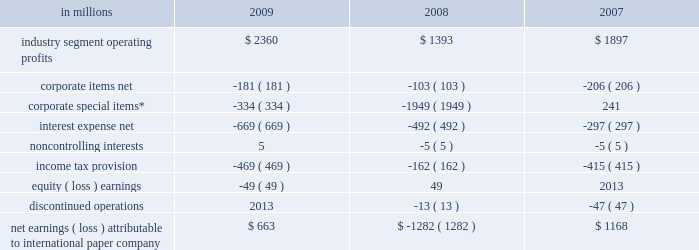Item 7 .
Management 2019s discussion and analysis of financial condition and results of operations executive summary international paper company reported net sales of $ 23.4 billion in 2009 , compared with $ 24.8 billion in 2008 and $ 21.9 billion in 2007 .
Net earnings totaled $ 663 million in 2009 , including $ 1.4 billion of alter- native fuel mixture credits and $ 853 million of charges to restructure ongoing businesses , com- pared with a loss of $ 1.3 billion in 2008 , which included a $ 1.8 billion goodwill impairment charge .
Net earnings in 2007 totaled $ 1.2 billion .
The company performed well in 2009 considering the magnitude of the challenges it faced , both domestically and around the world .
Despite weak global economic conditions , the company generated record cash flow from operations , enabling us to reduce long-term debt by $ 3.1 billion while increas- ing cash balances by approximately $ 800 million .
Also during 2009 , the company incurred 3.6 million tons of downtime , including 1.1 million tons asso- ciated with the shutdown of production capacity in our north american mill system to continue to match our production to our customers 2019 needs .
These actions should result in higher operating rates , lower fixed costs and lower payroll costs in 2010 and beyond .
Furthermore , the realization of integration synergies in our u.s .
Industrial packaging business and overhead reduction initiatives across the com- pany position international paper to benefit from a lower cost profile in future years .
As 2010 begins , we expect that first-quarter oper- ations will continue to be challenging .
In addition to being a seasonally slow quarter for many of our businesses , poor harvesting weather conditions in the u.s .
South and increasing competition for lim- ited supplies of recycled fiber are expected to lead to further increases in fiber costs for our u.s .
Mills .
Planned maintenance outage expenses will also be higher than in the 2009 fourth quarter .
However , we have announced product price increases for our major global manufacturing businesses , and while these actions may not have a significant effect on first-quarter results , we believe that the benefits beginning in the second quarter will be significant .
Additionally , we expect to benefit from the capacity management , cost reduction and integration synergy actions taken during 2009 .
As a result , the company remains positive about projected operating results in 2010 , with improved earnings versus 2009 expected in all major businesses .
We will continue to focus on aggressive cost management and strong cash flow generation as 2010 progresses .
Results of operations industry segment operating profits are used by inter- national paper 2019s management to measure the earn- ings performance of its businesses .
Management believes that this measure allows a better under- standing of trends in costs , operating efficiencies , prices and volumes .
Industry segment operating profits are defined as earnings before taxes , equity earnings , noncontrolling interests , interest expense , corporate items and corporate special items .
Industry segment operating profits are defined by the securities and exchange commission as a non-gaap financial measure , and are not gaap alternatives to net income or any other operating measure prescribed by accounting principles gen- erally accepted in the united states .
International paper operates in six segments : industrial packaging , printing papers , consumer packaging , distribution , forest products , and spe- cialty businesses and other .
The table shows the components of net earnings ( loss ) attributable to international paper company for each of the last three years : in millions 2009 2008 2007 .
Net earnings ( loss ) attributable to international paper company $ 663 $ ( 1282 ) $ 1168 * corporate special items include restructuring and other charg- es , goodwill impairment charges , gains on transformation plan forestland sales and net losses ( gains ) on sales and impairments of businesses .
Industry segment operating profits of $ 2.4 billion were $ 967 million higher in 2009 than in 2008 .
Oper- ating profits benefited from lower energy and raw material costs ( $ 447 million ) , lower distribution costs ( $ 142 million ) , favorable manufacturing operating costs ( $ 481 million ) , incremental earnings from the cbpr business acquired in the third quarter of 2008 ( $ 202 million ) , and other items ( $ 35 million ) , offset by lower average sales price realizations ( $ 444 million ) , lower sales volumes and increased lack-of-order downtime ( $ 684 million ) , unfavorable .
What is the average industry segment operating profits , in millions? 
Rationale: it is the sum of all values divided by three .
Computations: table_average(industry segment operating profits, none)
Answer: 1883.33333. 